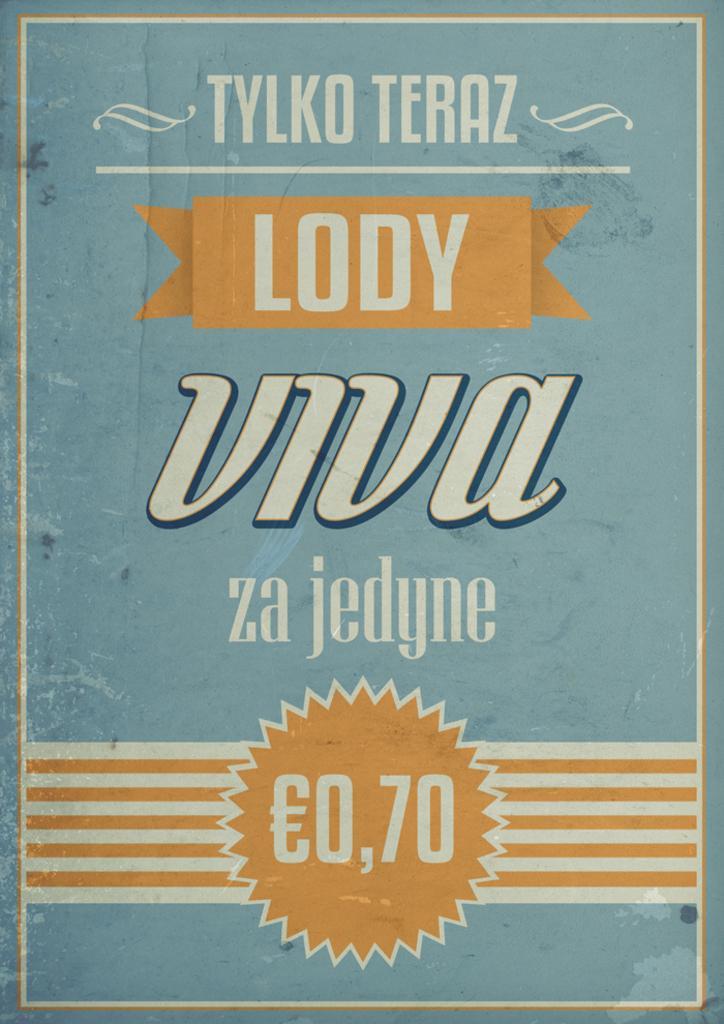How would you summarize this image in a sentence or two? There is a text presenting in this picture. 